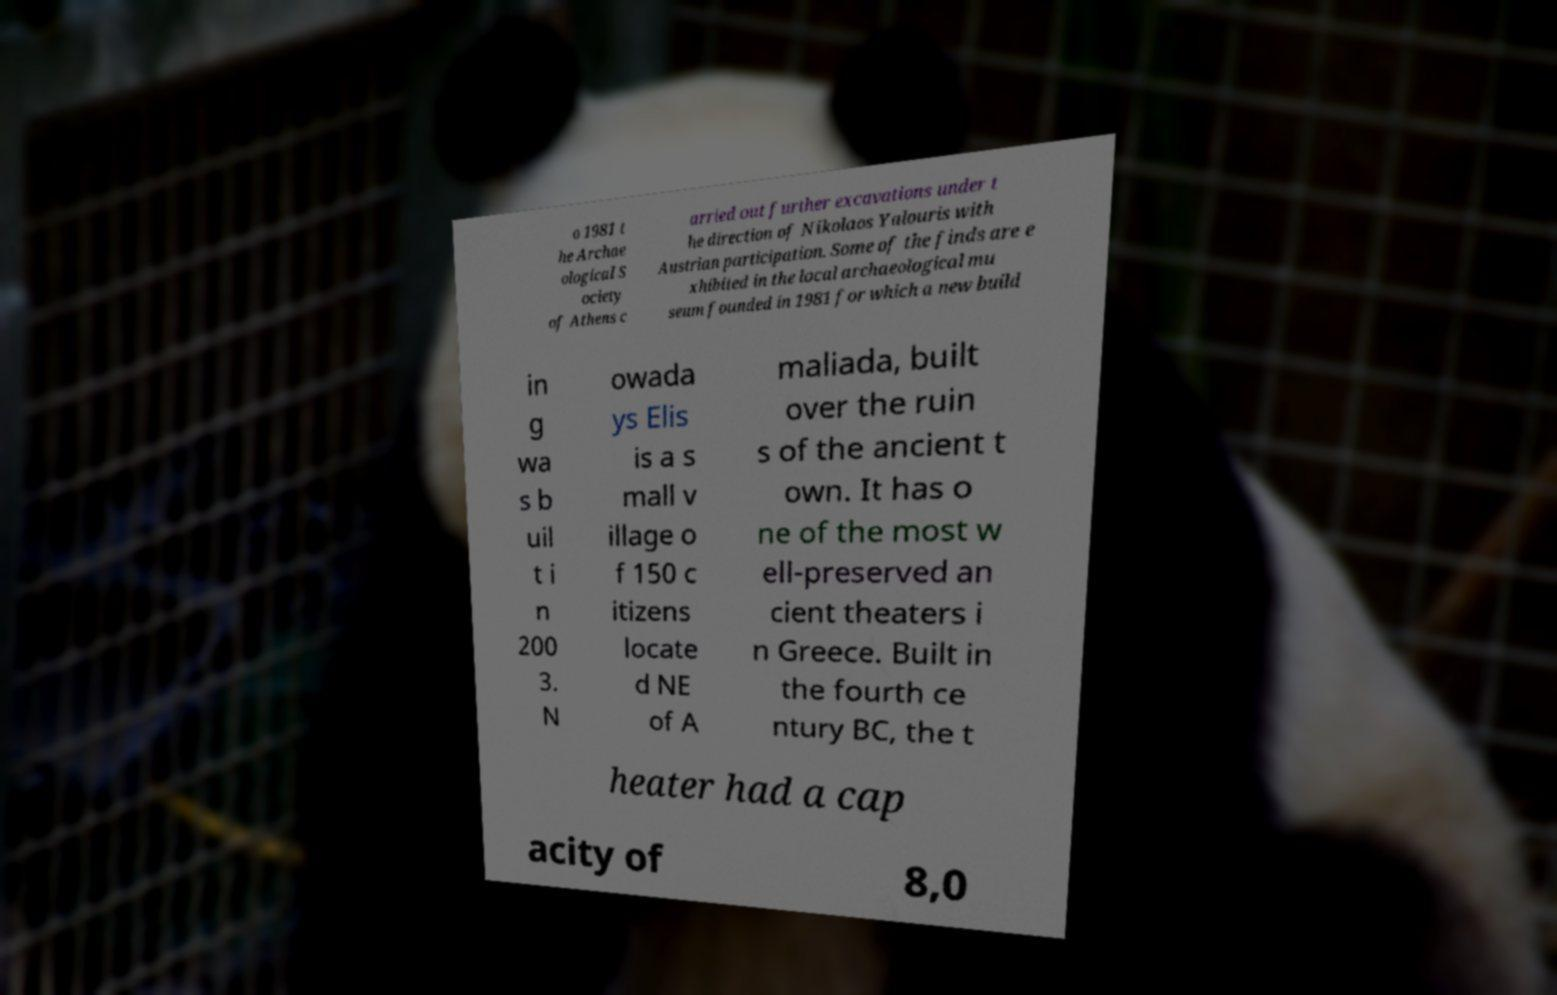Can you accurately transcribe the text from the provided image for me? o 1981 t he Archae ological S ociety of Athens c arried out further excavations under t he direction of Nikolaos Yalouris with Austrian participation. Some of the finds are e xhibited in the local archaeological mu seum founded in 1981 for which a new build in g wa s b uil t i n 200 3. N owada ys Elis is a s mall v illage o f 150 c itizens locate d NE of A maliada, built over the ruin s of the ancient t own. It has o ne of the most w ell-preserved an cient theaters i n Greece. Built in the fourth ce ntury BC, the t heater had a cap acity of 8,0 